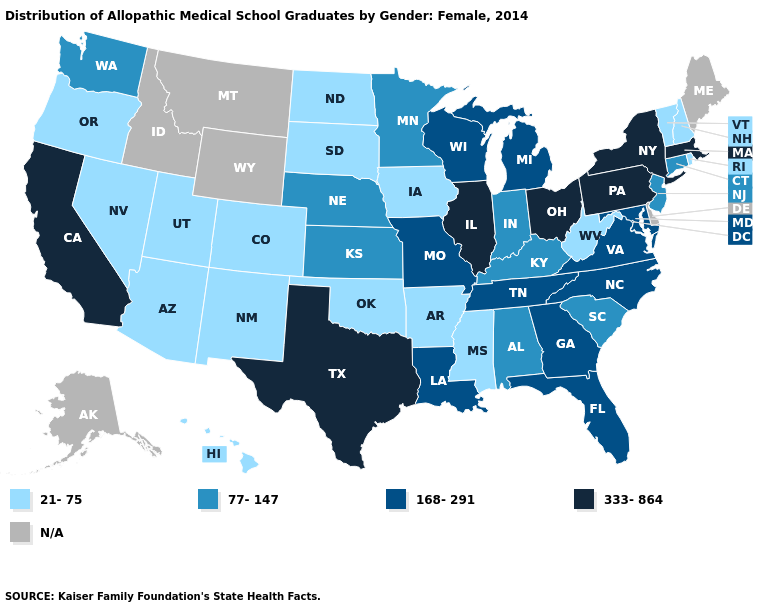What is the value of Hawaii?
Give a very brief answer. 21-75. What is the highest value in states that border Alabama?
Answer briefly. 168-291. Among the states that border Tennessee , does Missouri have the highest value?
Answer briefly. Yes. Among the states that border Arkansas , does Louisiana have the highest value?
Short answer required. No. Does Nevada have the highest value in the West?
Write a very short answer. No. Does Vermont have the lowest value in the USA?
Short answer required. Yes. What is the highest value in the MidWest ?
Be succinct. 333-864. What is the highest value in the West ?
Keep it brief. 333-864. Among the states that border Mississippi , which have the lowest value?
Keep it brief. Arkansas. Name the states that have a value in the range 77-147?
Concise answer only. Alabama, Connecticut, Indiana, Kansas, Kentucky, Minnesota, Nebraska, New Jersey, South Carolina, Washington. Among the states that border New York , which have the highest value?
Give a very brief answer. Massachusetts, Pennsylvania. Name the states that have a value in the range 77-147?
Be succinct. Alabama, Connecticut, Indiana, Kansas, Kentucky, Minnesota, Nebraska, New Jersey, South Carolina, Washington. What is the value of Georgia?
Quick response, please. 168-291. Does Rhode Island have the lowest value in the USA?
Quick response, please. Yes. 